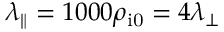<formula> <loc_0><loc_0><loc_500><loc_500>\lambda _ { \| } = 1 0 0 0 \rho _ { i 0 } = 4 \lambda _ { \perp }</formula> 